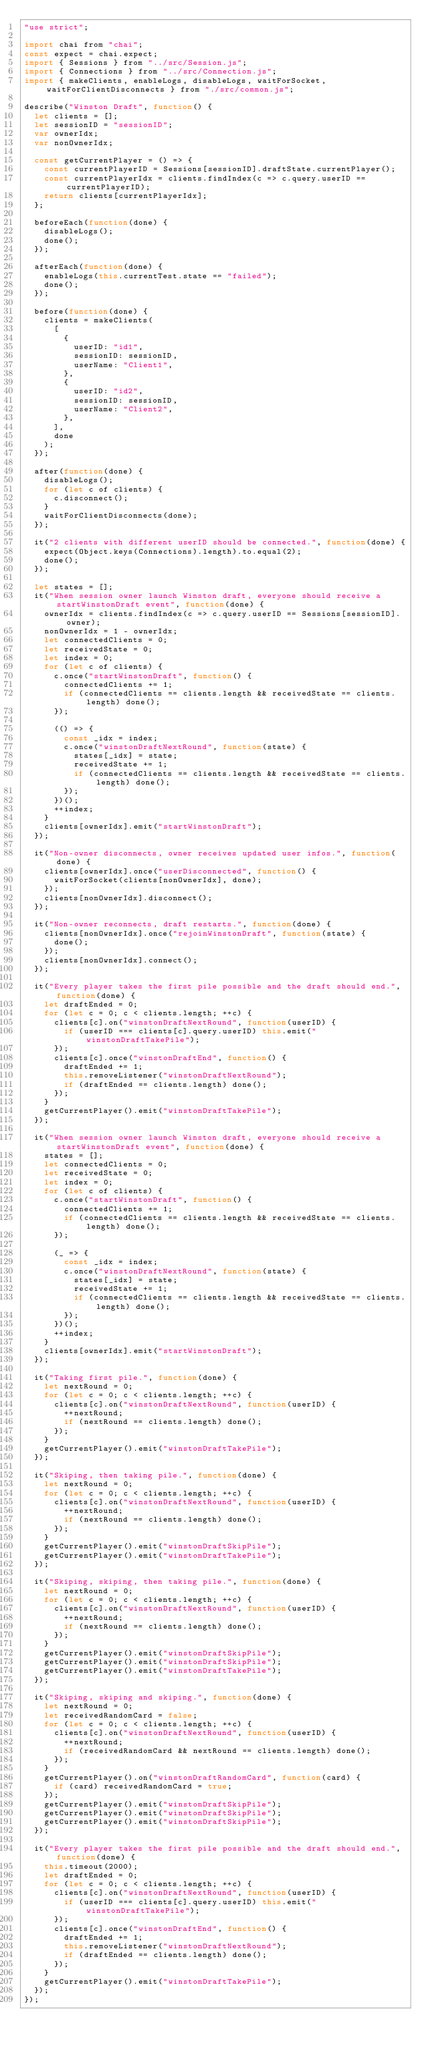Convert code to text. <code><loc_0><loc_0><loc_500><loc_500><_JavaScript_>"use strict";

import chai from "chai";
const expect = chai.expect;
import { Sessions } from "../src/Session.js";
import { Connections } from "../src/Connection.js";
import { makeClients, enableLogs, disableLogs, waitForSocket, waitForClientDisconnects } from "./src/common.js";

describe("Winston Draft", function() {
	let clients = [];
	let sessionID = "sessionID";
	var ownerIdx;
	var nonOwnerIdx;

	const getCurrentPlayer = () => {
		const currentPlayerID = Sessions[sessionID].draftState.currentPlayer();
		const currentPlayerIdx = clients.findIndex(c => c.query.userID == currentPlayerID);
		return clients[currentPlayerIdx];
	};

	beforeEach(function(done) {
		disableLogs();
		done();
	});

	afterEach(function(done) {
		enableLogs(this.currentTest.state == "failed");
		done();
	});

	before(function(done) {
		clients = makeClients(
			[
				{
					userID: "id1",
					sessionID: sessionID,
					userName: "Client1",
				},
				{
					userID: "id2",
					sessionID: sessionID,
					userName: "Client2",
				},
			],
			done
		);
	});

	after(function(done) {
		disableLogs();
		for (let c of clients) {
			c.disconnect();
		}
		waitForClientDisconnects(done);
	});

	it("2 clients with different userID should be connected.", function(done) {
		expect(Object.keys(Connections).length).to.equal(2);
		done();
	});

	let states = [];
	it("When session owner launch Winston draft, everyone should receive a startWinstonDraft event", function(done) {
		ownerIdx = clients.findIndex(c => c.query.userID == Sessions[sessionID].owner);
		nonOwnerIdx = 1 - ownerIdx;
		let connectedClients = 0;
		let receivedState = 0;
		let index = 0;
		for (let c of clients) {
			c.once("startWinstonDraft", function() {
				connectedClients += 1;
				if (connectedClients == clients.length && receivedState == clients.length) done();
			});

			(() => {
				const _idx = index;
				c.once("winstonDraftNextRound", function(state) {
					states[_idx] = state;
					receivedState += 1;
					if (connectedClients == clients.length && receivedState == clients.length) done();
				});
			})();
			++index;
		}
		clients[ownerIdx].emit("startWinstonDraft");
	});

	it("Non-owner disconnects, owner receives updated user infos.", function(done) {
		clients[ownerIdx].once("userDisconnected", function() {
			waitForSocket(clients[nonOwnerIdx], done);
		});
		clients[nonOwnerIdx].disconnect();
	});

	it("Non-owner reconnects, draft restarts.", function(done) {
		clients[nonOwnerIdx].once("rejoinWinstonDraft", function(state) {
			done();
		});
		clients[nonOwnerIdx].connect();
	});

	it("Every player takes the first pile possible and the draft should end.", function(done) {
		let draftEnded = 0;
		for (let c = 0; c < clients.length; ++c) {
			clients[c].on("winstonDraftNextRound", function(userID) {
				if (userID === clients[c].query.userID) this.emit("winstonDraftTakePile");
			});
			clients[c].once("winstonDraftEnd", function() {
				draftEnded += 1;
				this.removeListener("winstonDraftNextRound");
				if (draftEnded == clients.length) done();
			});
		}
		getCurrentPlayer().emit("winstonDraftTakePile");
	});

	it("When session owner launch Winston draft, everyone should receive a startWinstonDraft event", function(done) {
		states = [];
		let connectedClients = 0;
		let receivedState = 0;
		let index = 0;
		for (let c of clients) {
			c.once("startWinstonDraft", function() {
				connectedClients += 1;
				if (connectedClients == clients.length && receivedState == clients.length) done();
			});

			(_ => {
				const _idx = index;
				c.once("winstonDraftNextRound", function(state) {
					states[_idx] = state;
					receivedState += 1;
					if (connectedClients == clients.length && receivedState == clients.length) done();
				});
			})();
			++index;
		}
		clients[ownerIdx].emit("startWinstonDraft");
	});

	it("Taking first pile.", function(done) {
		let nextRound = 0;
		for (let c = 0; c < clients.length; ++c) {
			clients[c].on("winstonDraftNextRound", function(userID) {
				++nextRound;
				if (nextRound == clients.length) done();
			});
		}
		getCurrentPlayer().emit("winstonDraftTakePile");
	});

	it("Skiping, then taking pile.", function(done) {
		let nextRound = 0;
		for (let c = 0; c < clients.length; ++c) {
			clients[c].on("winstonDraftNextRound", function(userID) {
				++nextRound;
				if (nextRound == clients.length) done();
			});
		}
		getCurrentPlayer().emit("winstonDraftSkipPile");
		getCurrentPlayer().emit("winstonDraftTakePile");
	});

	it("Skiping, skiping, then taking pile.", function(done) {
		let nextRound = 0;
		for (let c = 0; c < clients.length; ++c) {
			clients[c].on("winstonDraftNextRound", function(userID) {
				++nextRound;
				if (nextRound == clients.length) done();
			});
		}
		getCurrentPlayer().emit("winstonDraftSkipPile");
		getCurrentPlayer().emit("winstonDraftSkipPile");
		getCurrentPlayer().emit("winstonDraftTakePile");
	});

	it("Skiping, skiping and skiping.", function(done) {
		let nextRound = 0;
		let receivedRandomCard = false;
		for (let c = 0; c < clients.length; ++c) {
			clients[c].on("winstonDraftNextRound", function(userID) {
				++nextRound;
				if (receivedRandomCard && nextRound == clients.length) done();
			});
		}
		getCurrentPlayer().on("winstonDraftRandomCard", function(card) {
			if (card) receivedRandomCard = true;
		});
		getCurrentPlayer().emit("winstonDraftSkipPile");
		getCurrentPlayer().emit("winstonDraftSkipPile");
		getCurrentPlayer().emit("winstonDraftSkipPile");
	});

	it("Every player takes the first pile possible and the draft should end.", function(done) {
		this.timeout(2000);
		let draftEnded = 0;
		for (let c = 0; c < clients.length; ++c) {
			clients[c].on("winstonDraftNextRound", function(userID) {
				if (userID === clients[c].query.userID) this.emit("winstonDraftTakePile");
			});
			clients[c].once("winstonDraftEnd", function() {
				draftEnded += 1;
				this.removeListener("winstonDraftNextRound");
				if (draftEnded == clients.length) done();
			});
		}
		getCurrentPlayer().emit("winstonDraftTakePile");
	});
});
</code> 